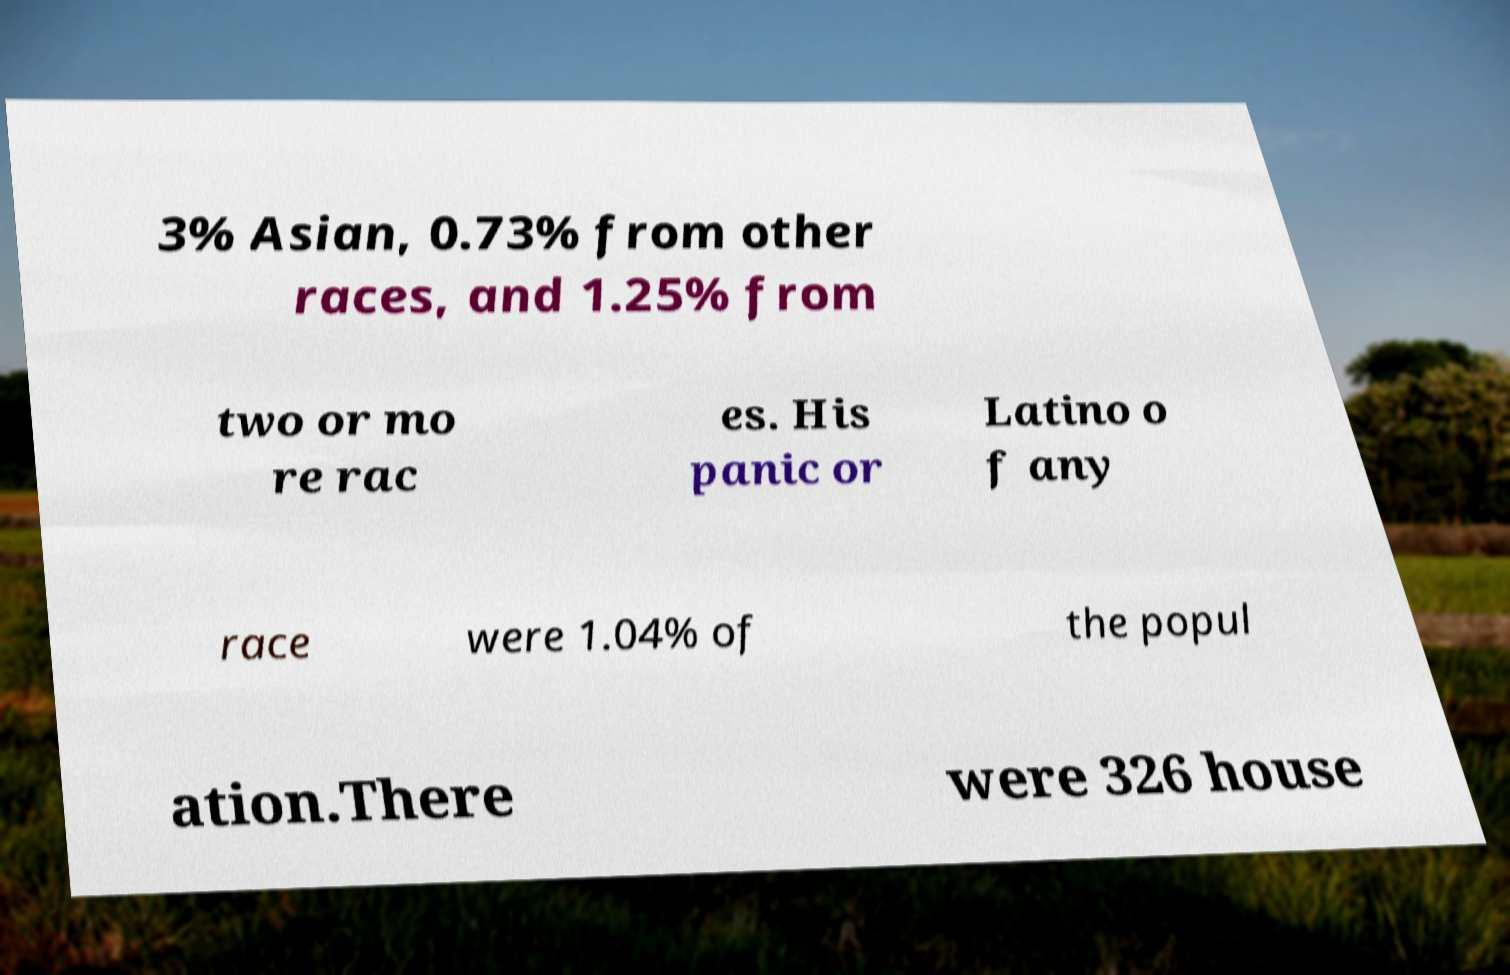Can you accurately transcribe the text from the provided image for me? 3% Asian, 0.73% from other races, and 1.25% from two or mo re rac es. His panic or Latino o f any race were 1.04% of the popul ation.There were 326 house 